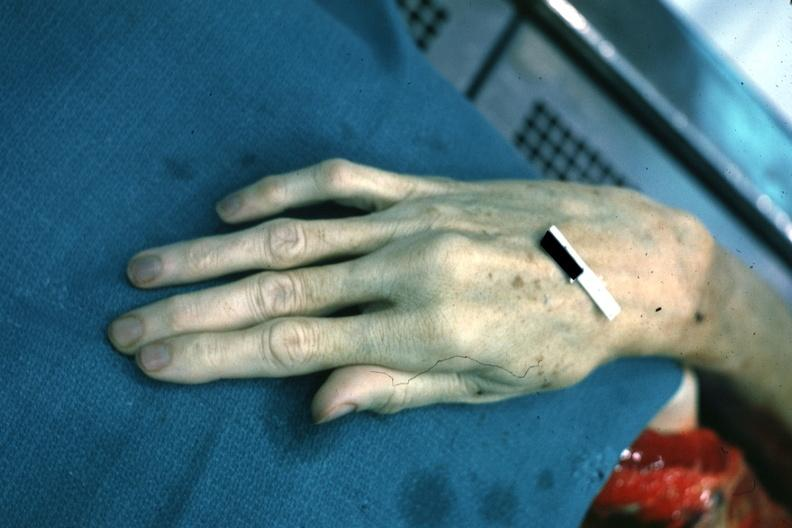what are present?
Answer the question using a single word or phrase. Extremities 